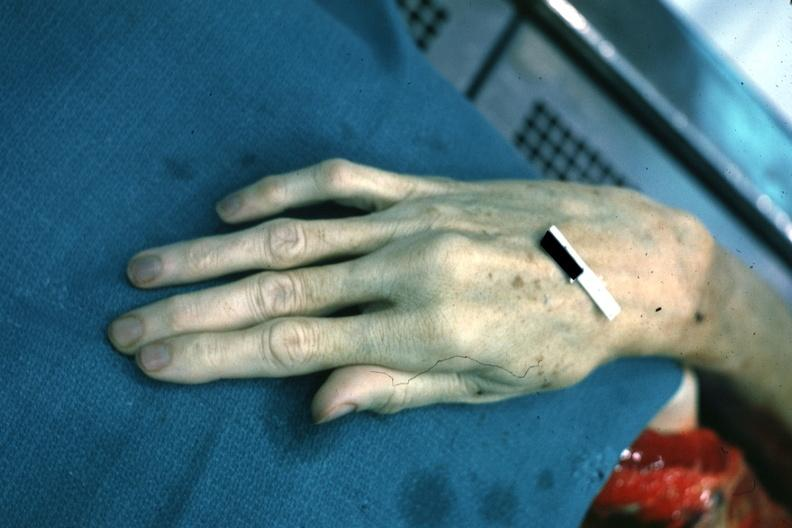what are present?
Answer the question using a single word or phrase. Extremities 